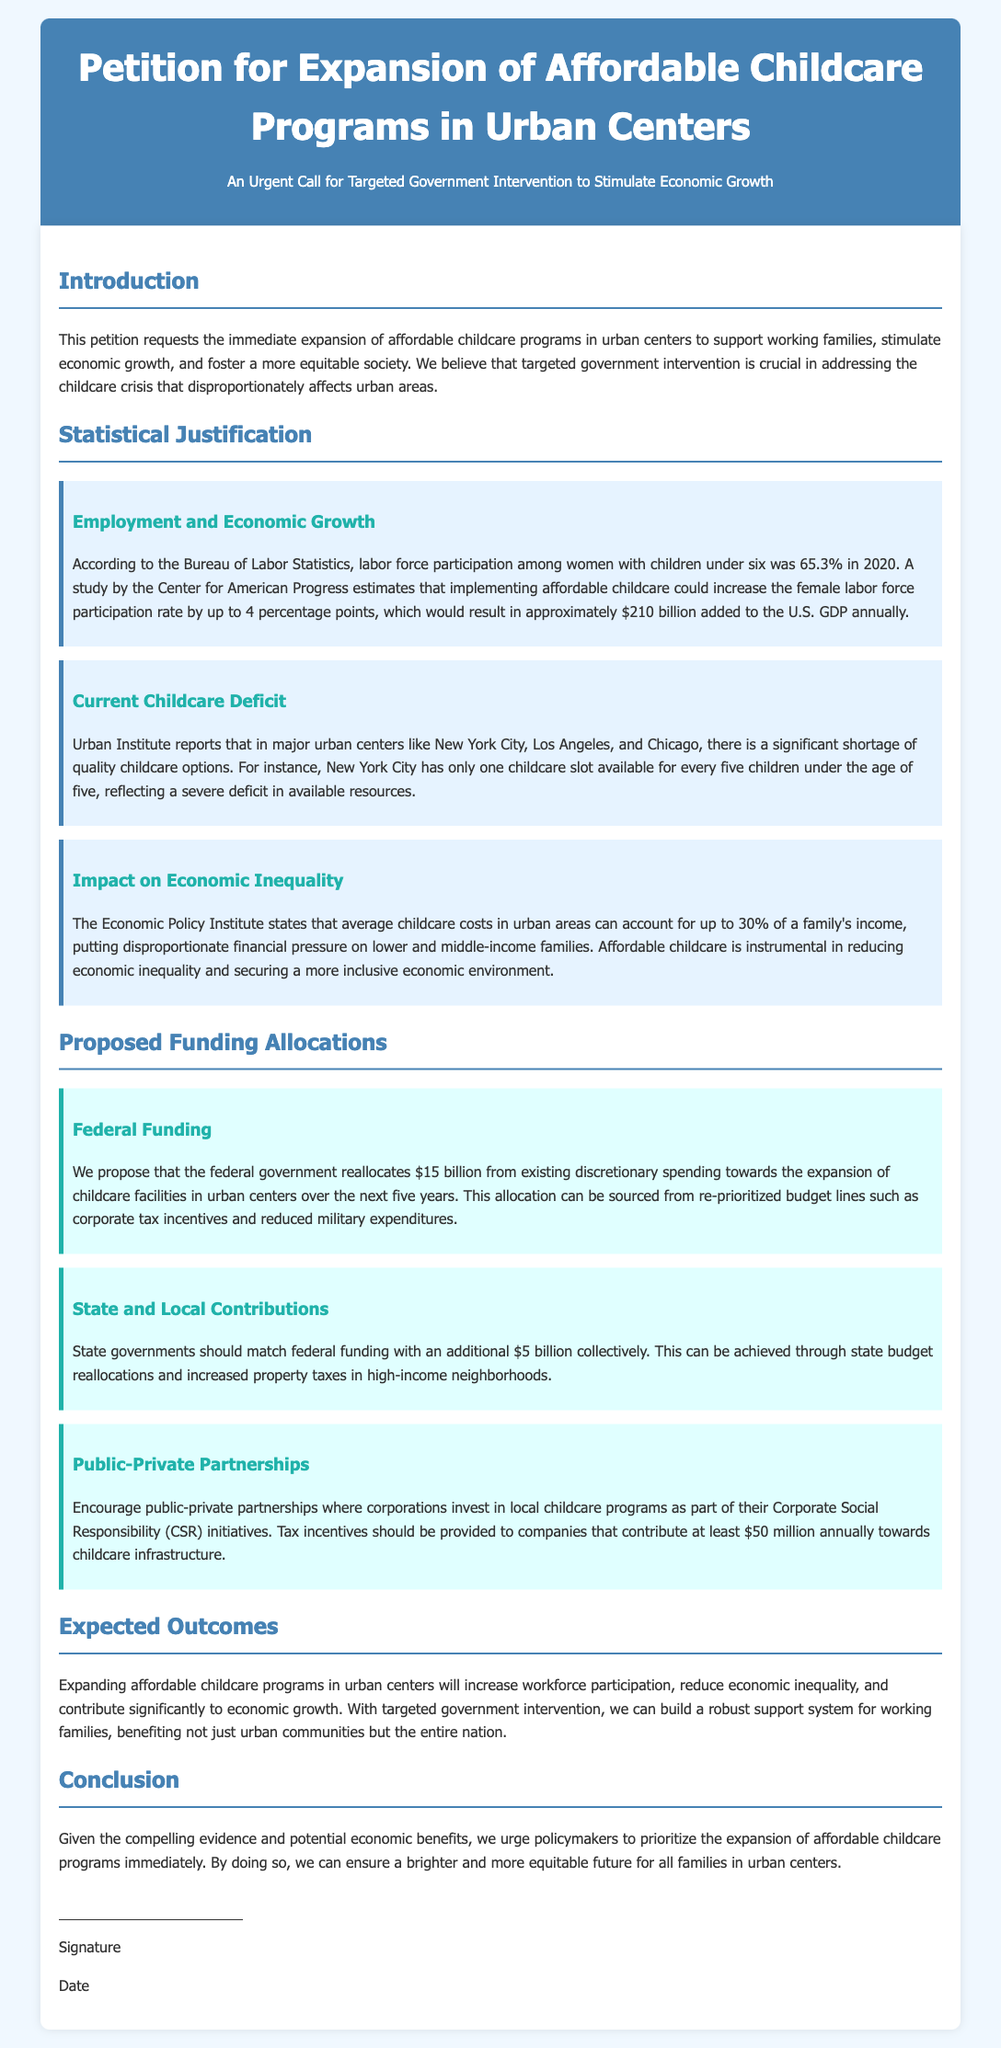what percentage of women with children under six participated in the labor force in 2020? The document states that the labor force participation among women with children under six was 65.3% in 2020.
Answer: 65.3% how much could affordable childcare potentially add to the U.S. GDP annually? According to the document, implementing affordable childcare could result in approximately $210 billion added to the U.S. GDP annually.
Answer: $210 billion how many childcare slots are available for children under five in New York City? The document mentions that New York City has only one childcare slot available for every five children under the age of five, indicating a severe deficit.
Answer: One for every five what is the proposed federal funding amount for childcare facility expansion? The document proposes that the federal government reallocates $15 billion towards the expansion of childcare facilities in urban centers.
Answer: $15 billion what percentage of a family's income can childcare costs account for in urban areas? The Economic Policy Institute states that average childcare costs in urban areas can account for up to 30% of a family's income.
Answer: 30% how much additional funding do state governments need to provide collectively? The document states that state governments should match federal funding with an additional $5 billion collectively.
Answer: $5 billion what should corporations invest in as part of their Corporate Social Responsibility initiatives? The document suggests that corporations invest in local childcare programs as part of their Corporate Social Responsibility initiatives.
Answer: Local childcare programs what is the primary concern addressed in the conclusion of the petition? The document urges policymakers to prioritize the expansion of affordable childcare programs immediately based on compelling evidence and potential benefits.
Answer: Expansion of affordable childcare programs how many years is the proposed federal funding allocation planned to occur over? The document states that the proposed federal funding is allocated over the next five years.
Answer: Five years 